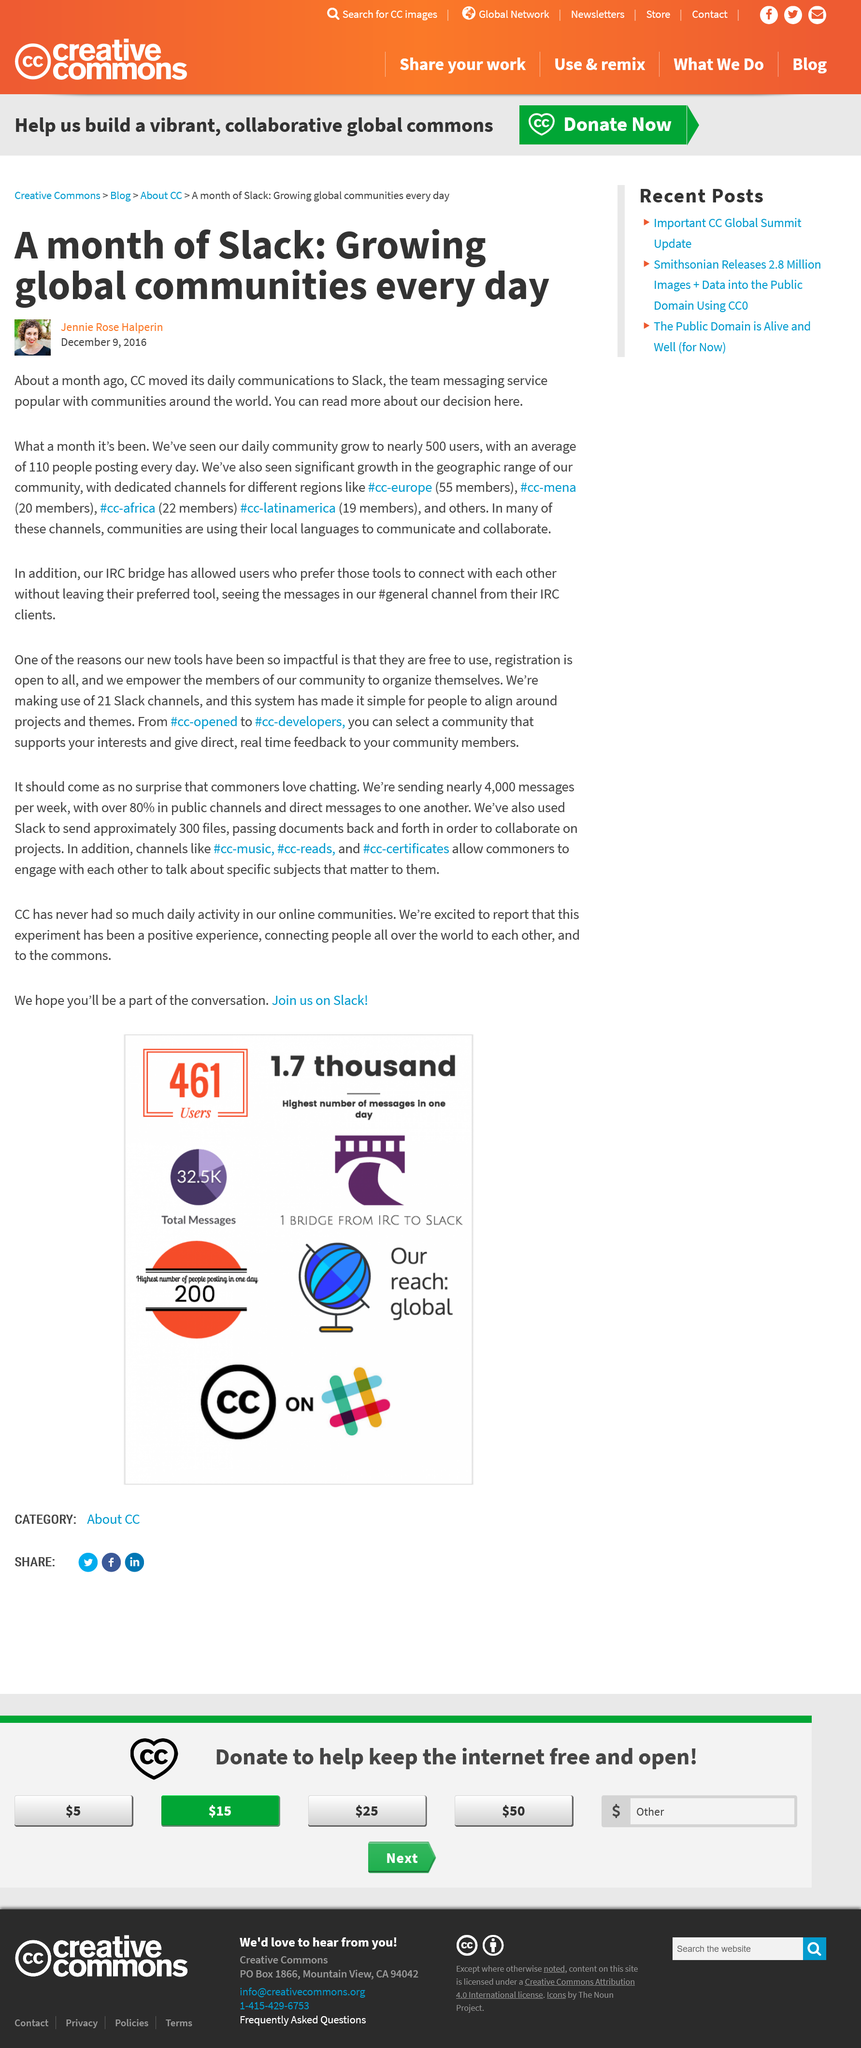Highlight a few significant elements in this photo. As of today, the community has an average of 110 people posting every day. CC transferred its daily communication to Slack approximately one month ago. 